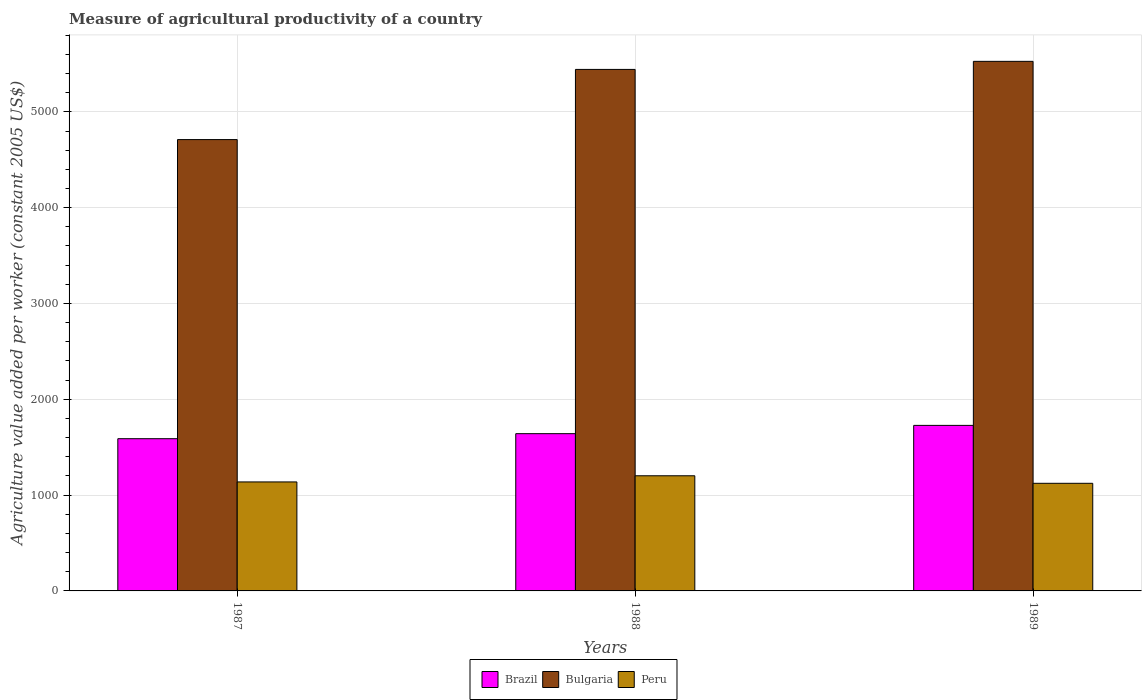Are the number of bars on each tick of the X-axis equal?
Your answer should be very brief. Yes. What is the label of the 3rd group of bars from the left?
Ensure brevity in your answer.  1989. In how many cases, is the number of bars for a given year not equal to the number of legend labels?
Your answer should be compact. 0. What is the measure of agricultural productivity in Peru in 1988?
Your answer should be very brief. 1201.82. Across all years, what is the maximum measure of agricultural productivity in Bulgaria?
Provide a succinct answer. 5526.9. Across all years, what is the minimum measure of agricultural productivity in Bulgaria?
Offer a very short reply. 4710.43. What is the total measure of agricultural productivity in Peru in the graph?
Your answer should be compact. 3462.48. What is the difference between the measure of agricultural productivity in Peru in 1987 and that in 1989?
Your answer should be very brief. 14.3. What is the difference between the measure of agricultural productivity in Bulgaria in 1988 and the measure of agricultural productivity in Brazil in 1987?
Offer a very short reply. 3853.97. What is the average measure of agricultural productivity in Peru per year?
Provide a short and direct response. 1154.16. In the year 1989, what is the difference between the measure of agricultural productivity in Peru and measure of agricultural productivity in Bulgaria?
Keep it short and to the point. -4403.71. In how many years, is the measure of agricultural productivity in Bulgaria greater than 1800 US$?
Offer a very short reply. 3. What is the ratio of the measure of agricultural productivity in Peru in 1987 to that in 1989?
Make the answer very short. 1.01. Is the difference between the measure of agricultural productivity in Peru in 1987 and 1988 greater than the difference between the measure of agricultural productivity in Bulgaria in 1987 and 1988?
Your answer should be very brief. Yes. What is the difference between the highest and the second highest measure of agricultural productivity in Peru?
Make the answer very short. 64.34. What is the difference between the highest and the lowest measure of agricultural productivity in Brazil?
Keep it short and to the point. 138.98. In how many years, is the measure of agricultural productivity in Bulgaria greater than the average measure of agricultural productivity in Bulgaria taken over all years?
Keep it short and to the point. 2. Is the sum of the measure of agricultural productivity in Bulgaria in 1988 and 1989 greater than the maximum measure of agricultural productivity in Brazil across all years?
Give a very brief answer. Yes. What does the 2nd bar from the left in 1987 represents?
Ensure brevity in your answer.  Bulgaria. What does the 2nd bar from the right in 1987 represents?
Your answer should be compact. Bulgaria. Is it the case that in every year, the sum of the measure of agricultural productivity in Peru and measure of agricultural productivity in Brazil is greater than the measure of agricultural productivity in Bulgaria?
Your answer should be very brief. No. Are all the bars in the graph horizontal?
Ensure brevity in your answer.  No. Does the graph contain any zero values?
Keep it short and to the point. No. Where does the legend appear in the graph?
Your answer should be compact. Bottom center. What is the title of the graph?
Make the answer very short. Measure of agricultural productivity of a country. Does "Aruba" appear as one of the legend labels in the graph?
Offer a very short reply. No. What is the label or title of the Y-axis?
Your response must be concise. Agriculture value added per worker (constant 2005 US$). What is the Agriculture value added per worker (constant 2005 US$) of Brazil in 1987?
Provide a short and direct response. 1588.76. What is the Agriculture value added per worker (constant 2005 US$) of Bulgaria in 1987?
Provide a short and direct response. 4710.43. What is the Agriculture value added per worker (constant 2005 US$) of Peru in 1987?
Make the answer very short. 1137.48. What is the Agriculture value added per worker (constant 2005 US$) in Brazil in 1988?
Provide a succinct answer. 1641.28. What is the Agriculture value added per worker (constant 2005 US$) of Bulgaria in 1988?
Keep it short and to the point. 5442.72. What is the Agriculture value added per worker (constant 2005 US$) in Peru in 1988?
Make the answer very short. 1201.82. What is the Agriculture value added per worker (constant 2005 US$) of Brazil in 1989?
Offer a very short reply. 1727.74. What is the Agriculture value added per worker (constant 2005 US$) in Bulgaria in 1989?
Give a very brief answer. 5526.9. What is the Agriculture value added per worker (constant 2005 US$) of Peru in 1989?
Keep it short and to the point. 1123.18. Across all years, what is the maximum Agriculture value added per worker (constant 2005 US$) in Brazil?
Provide a short and direct response. 1727.74. Across all years, what is the maximum Agriculture value added per worker (constant 2005 US$) in Bulgaria?
Provide a succinct answer. 5526.9. Across all years, what is the maximum Agriculture value added per worker (constant 2005 US$) in Peru?
Provide a short and direct response. 1201.82. Across all years, what is the minimum Agriculture value added per worker (constant 2005 US$) of Brazil?
Provide a short and direct response. 1588.76. Across all years, what is the minimum Agriculture value added per worker (constant 2005 US$) of Bulgaria?
Give a very brief answer. 4710.43. Across all years, what is the minimum Agriculture value added per worker (constant 2005 US$) in Peru?
Ensure brevity in your answer.  1123.18. What is the total Agriculture value added per worker (constant 2005 US$) of Brazil in the graph?
Keep it short and to the point. 4957.78. What is the total Agriculture value added per worker (constant 2005 US$) in Bulgaria in the graph?
Make the answer very short. 1.57e+04. What is the total Agriculture value added per worker (constant 2005 US$) of Peru in the graph?
Your answer should be compact. 3462.48. What is the difference between the Agriculture value added per worker (constant 2005 US$) of Brazil in 1987 and that in 1988?
Keep it short and to the point. -52.53. What is the difference between the Agriculture value added per worker (constant 2005 US$) in Bulgaria in 1987 and that in 1988?
Offer a terse response. -732.3. What is the difference between the Agriculture value added per worker (constant 2005 US$) in Peru in 1987 and that in 1988?
Provide a short and direct response. -64.34. What is the difference between the Agriculture value added per worker (constant 2005 US$) in Brazil in 1987 and that in 1989?
Keep it short and to the point. -138.98. What is the difference between the Agriculture value added per worker (constant 2005 US$) of Bulgaria in 1987 and that in 1989?
Offer a very short reply. -816.47. What is the difference between the Agriculture value added per worker (constant 2005 US$) in Peru in 1987 and that in 1989?
Provide a succinct answer. 14.3. What is the difference between the Agriculture value added per worker (constant 2005 US$) in Brazil in 1988 and that in 1989?
Keep it short and to the point. -86.46. What is the difference between the Agriculture value added per worker (constant 2005 US$) of Bulgaria in 1988 and that in 1989?
Your answer should be compact. -84.17. What is the difference between the Agriculture value added per worker (constant 2005 US$) of Peru in 1988 and that in 1989?
Give a very brief answer. 78.64. What is the difference between the Agriculture value added per worker (constant 2005 US$) in Brazil in 1987 and the Agriculture value added per worker (constant 2005 US$) in Bulgaria in 1988?
Provide a succinct answer. -3853.97. What is the difference between the Agriculture value added per worker (constant 2005 US$) in Brazil in 1987 and the Agriculture value added per worker (constant 2005 US$) in Peru in 1988?
Offer a terse response. 386.94. What is the difference between the Agriculture value added per worker (constant 2005 US$) in Bulgaria in 1987 and the Agriculture value added per worker (constant 2005 US$) in Peru in 1988?
Give a very brief answer. 3508.6. What is the difference between the Agriculture value added per worker (constant 2005 US$) of Brazil in 1987 and the Agriculture value added per worker (constant 2005 US$) of Bulgaria in 1989?
Offer a very short reply. -3938.14. What is the difference between the Agriculture value added per worker (constant 2005 US$) in Brazil in 1987 and the Agriculture value added per worker (constant 2005 US$) in Peru in 1989?
Give a very brief answer. 465.57. What is the difference between the Agriculture value added per worker (constant 2005 US$) of Bulgaria in 1987 and the Agriculture value added per worker (constant 2005 US$) of Peru in 1989?
Offer a terse response. 3587.24. What is the difference between the Agriculture value added per worker (constant 2005 US$) of Brazil in 1988 and the Agriculture value added per worker (constant 2005 US$) of Bulgaria in 1989?
Your answer should be very brief. -3885.61. What is the difference between the Agriculture value added per worker (constant 2005 US$) in Brazil in 1988 and the Agriculture value added per worker (constant 2005 US$) in Peru in 1989?
Provide a succinct answer. 518.1. What is the difference between the Agriculture value added per worker (constant 2005 US$) of Bulgaria in 1988 and the Agriculture value added per worker (constant 2005 US$) of Peru in 1989?
Offer a very short reply. 4319.54. What is the average Agriculture value added per worker (constant 2005 US$) in Brazil per year?
Your answer should be compact. 1652.59. What is the average Agriculture value added per worker (constant 2005 US$) of Bulgaria per year?
Offer a terse response. 5226.68. What is the average Agriculture value added per worker (constant 2005 US$) in Peru per year?
Keep it short and to the point. 1154.16. In the year 1987, what is the difference between the Agriculture value added per worker (constant 2005 US$) of Brazil and Agriculture value added per worker (constant 2005 US$) of Bulgaria?
Your answer should be very brief. -3121.67. In the year 1987, what is the difference between the Agriculture value added per worker (constant 2005 US$) in Brazil and Agriculture value added per worker (constant 2005 US$) in Peru?
Ensure brevity in your answer.  451.28. In the year 1987, what is the difference between the Agriculture value added per worker (constant 2005 US$) in Bulgaria and Agriculture value added per worker (constant 2005 US$) in Peru?
Give a very brief answer. 3572.95. In the year 1988, what is the difference between the Agriculture value added per worker (constant 2005 US$) in Brazil and Agriculture value added per worker (constant 2005 US$) in Bulgaria?
Your answer should be very brief. -3801.44. In the year 1988, what is the difference between the Agriculture value added per worker (constant 2005 US$) of Brazil and Agriculture value added per worker (constant 2005 US$) of Peru?
Make the answer very short. 439.46. In the year 1988, what is the difference between the Agriculture value added per worker (constant 2005 US$) of Bulgaria and Agriculture value added per worker (constant 2005 US$) of Peru?
Provide a short and direct response. 4240.9. In the year 1989, what is the difference between the Agriculture value added per worker (constant 2005 US$) of Brazil and Agriculture value added per worker (constant 2005 US$) of Bulgaria?
Your answer should be very brief. -3799.16. In the year 1989, what is the difference between the Agriculture value added per worker (constant 2005 US$) of Brazil and Agriculture value added per worker (constant 2005 US$) of Peru?
Your response must be concise. 604.56. In the year 1989, what is the difference between the Agriculture value added per worker (constant 2005 US$) in Bulgaria and Agriculture value added per worker (constant 2005 US$) in Peru?
Offer a very short reply. 4403.71. What is the ratio of the Agriculture value added per worker (constant 2005 US$) in Brazil in 1987 to that in 1988?
Make the answer very short. 0.97. What is the ratio of the Agriculture value added per worker (constant 2005 US$) of Bulgaria in 1987 to that in 1988?
Give a very brief answer. 0.87. What is the ratio of the Agriculture value added per worker (constant 2005 US$) in Peru in 1987 to that in 1988?
Your answer should be very brief. 0.95. What is the ratio of the Agriculture value added per worker (constant 2005 US$) in Brazil in 1987 to that in 1989?
Provide a short and direct response. 0.92. What is the ratio of the Agriculture value added per worker (constant 2005 US$) of Bulgaria in 1987 to that in 1989?
Provide a short and direct response. 0.85. What is the ratio of the Agriculture value added per worker (constant 2005 US$) of Peru in 1987 to that in 1989?
Offer a very short reply. 1.01. What is the ratio of the Agriculture value added per worker (constant 2005 US$) in Bulgaria in 1988 to that in 1989?
Give a very brief answer. 0.98. What is the ratio of the Agriculture value added per worker (constant 2005 US$) of Peru in 1988 to that in 1989?
Provide a short and direct response. 1.07. What is the difference between the highest and the second highest Agriculture value added per worker (constant 2005 US$) in Brazil?
Offer a terse response. 86.46. What is the difference between the highest and the second highest Agriculture value added per worker (constant 2005 US$) in Bulgaria?
Ensure brevity in your answer.  84.17. What is the difference between the highest and the second highest Agriculture value added per worker (constant 2005 US$) in Peru?
Provide a succinct answer. 64.34. What is the difference between the highest and the lowest Agriculture value added per worker (constant 2005 US$) in Brazil?
Your response must be concise. 138.98. What is the difference between the highest and the lowest Agriculture value added per worker (constant 2005 US$) in Bulgaria?
Your answer should be compact. 816.47. What is the difference between the highest and the lowest Agriculture value added per worker (constant 2005 US$) in Peru?
Your response must be concise. 78.64. 